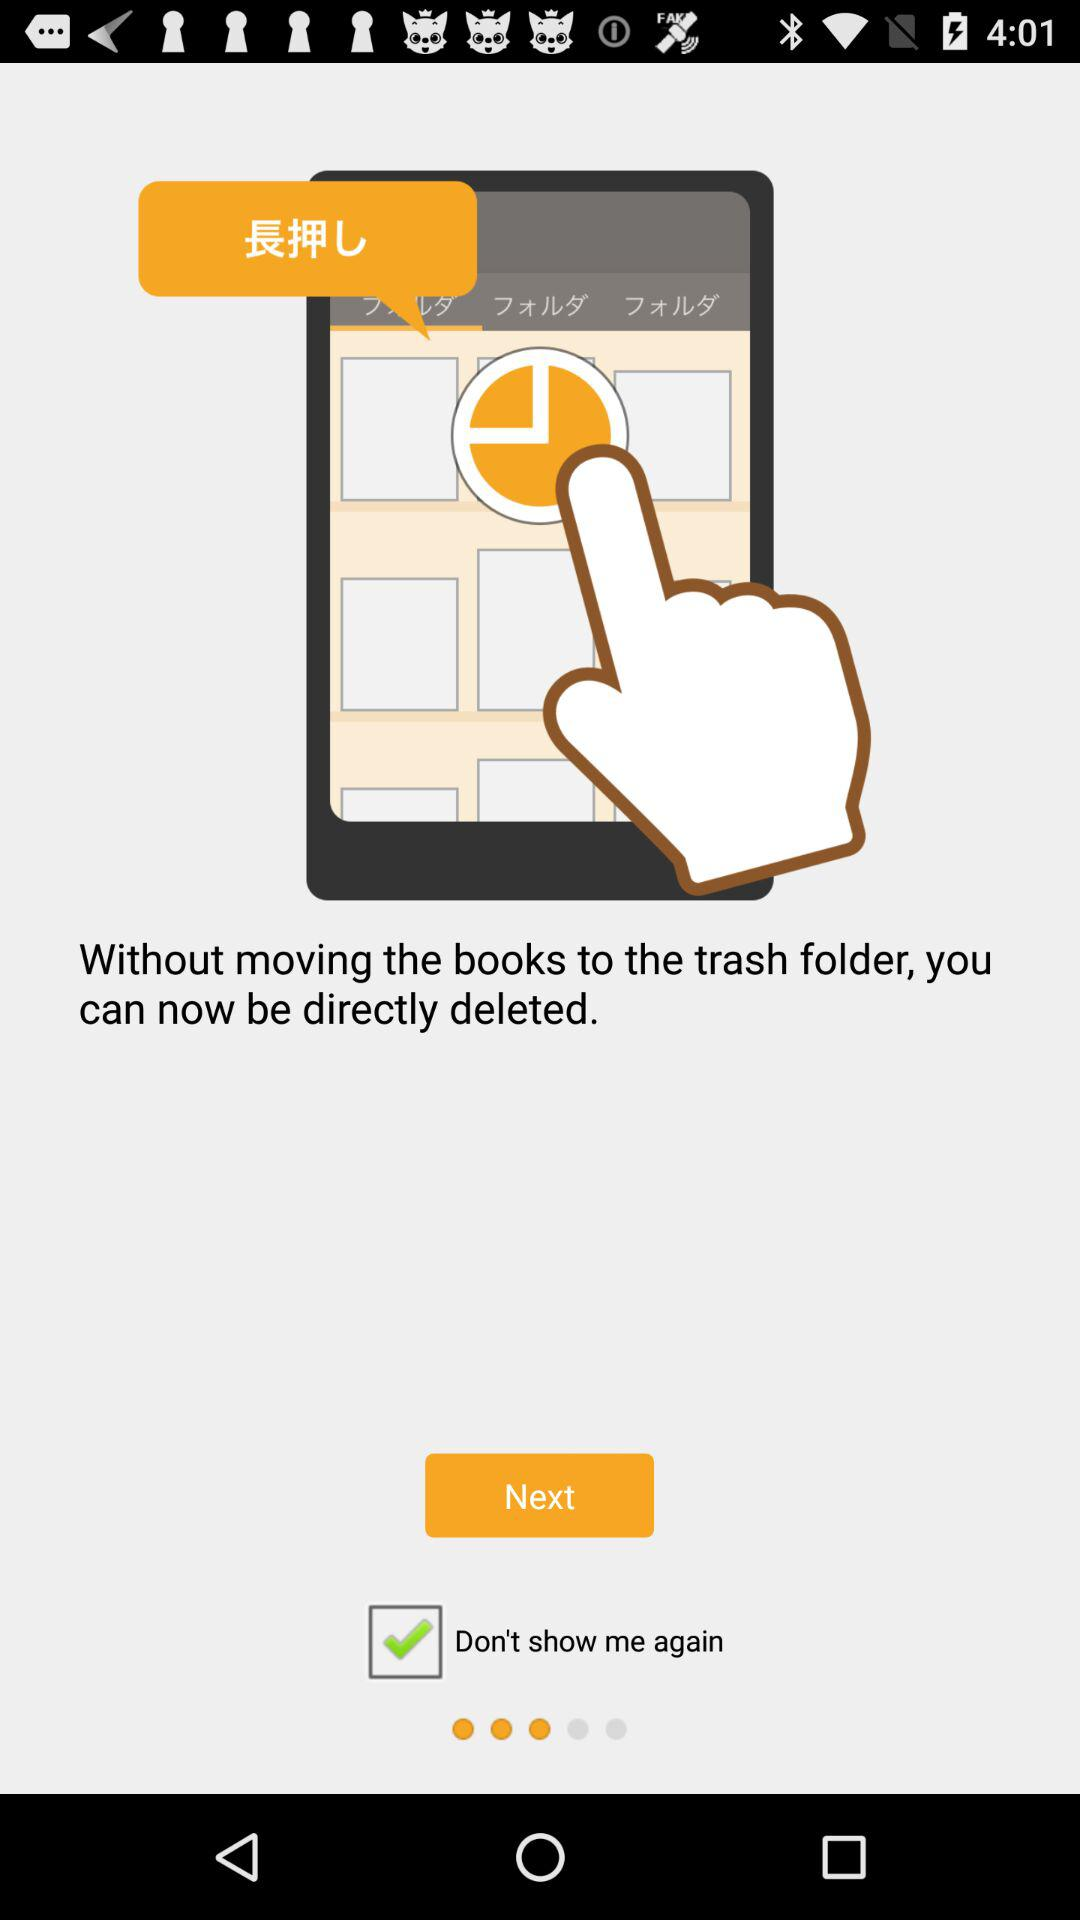What is the status of "Don't show me again"? The status of "Don't show me again" is "on". 